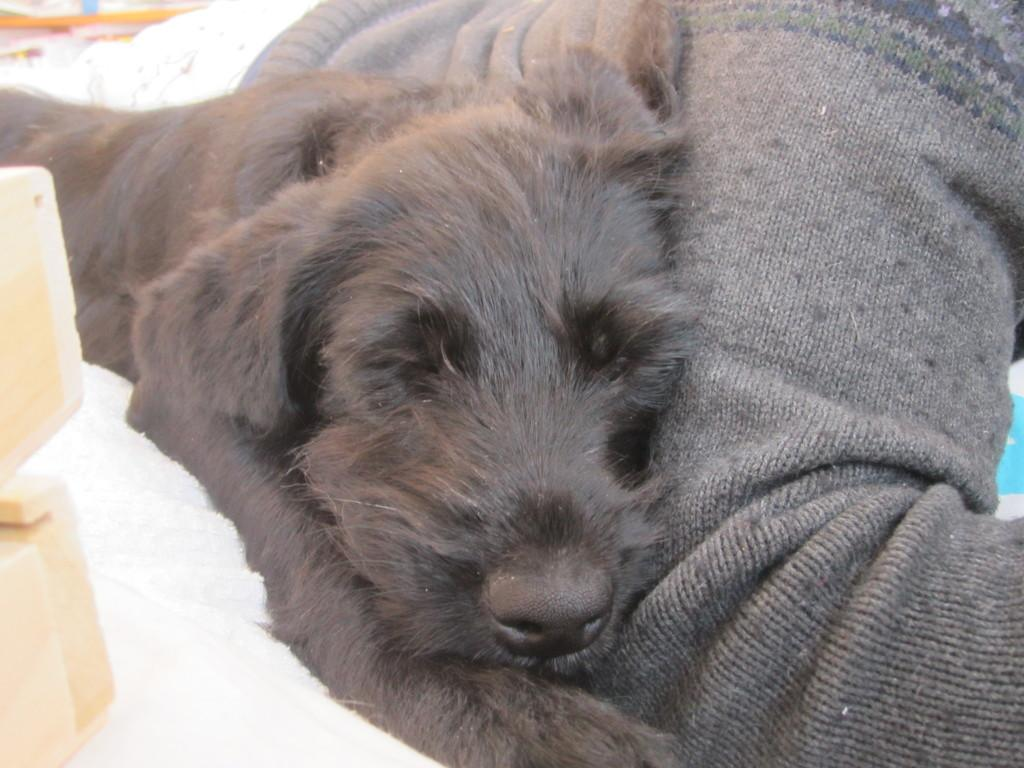What type of animal is present in the image? There is a dog in the image. What is the person in the image doing? The person is laying on the ground in the image. What can be seen on the left side of the image? There are wood pieces on the left side of the image. How many bikes are present in the image? There are no bikes present in the image. What type of coal can be seen in the image? There is no coal present in the image. 